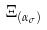Convert formula to latex. <formula><loc_0><loc_0><loc_500><loc_500>\Xi _ { ( \alpha _ { \sigma } ) }</formula> 